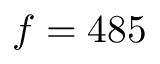Convert formula to latex. <formula><loc_0><loc_0><loc_500><loc_500>f = 4 8 5</formula> 